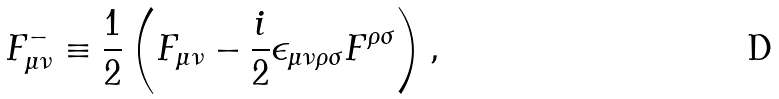Convert formula to latex. <formula><loc_0><loc_0><loc_500><loc_500>F _ { \mu \nu } ^ { - } \equiv \frac { 1 } { 2 } \left ( F _ { \mu \nu } - \frac { i } { 2 } \epsilon _ { \mu \nu \rho \sigma } F ^ { \rho \sigma } \right ) ,</formula> 